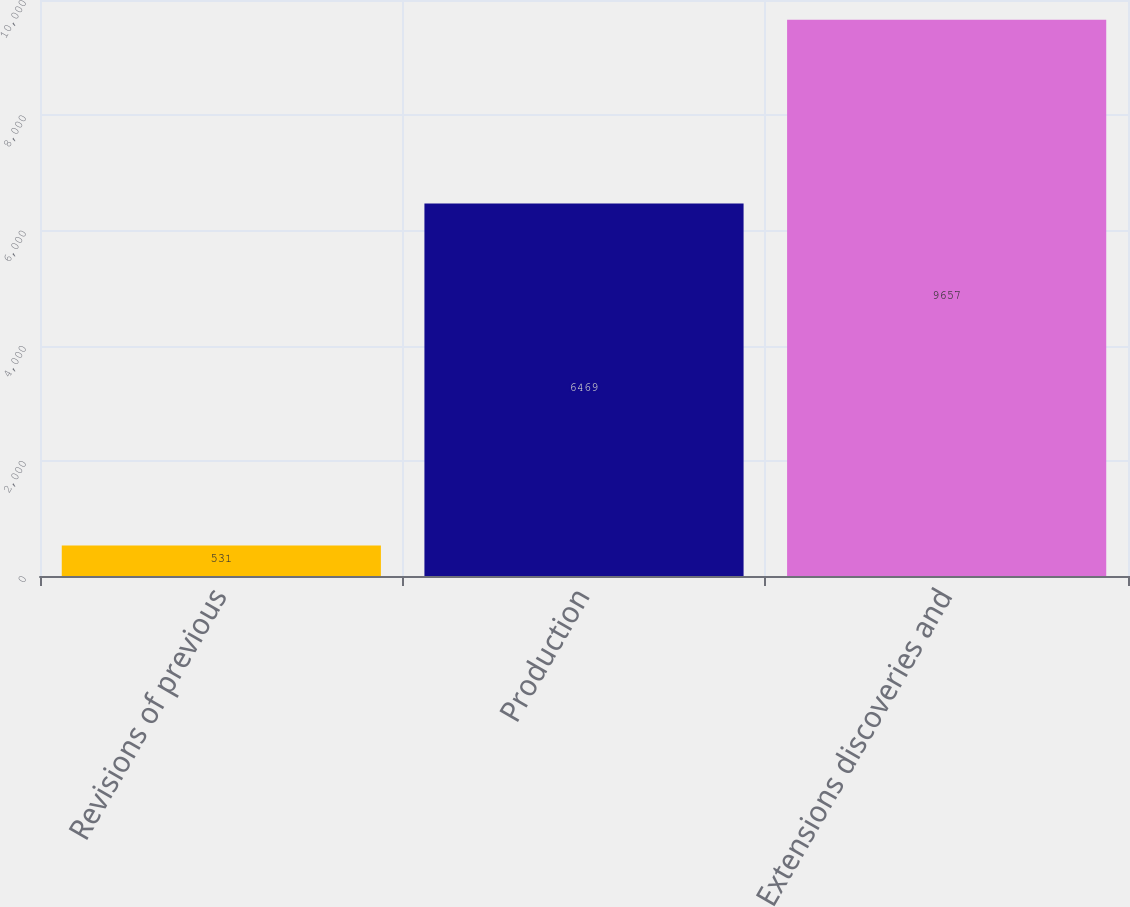Convert chart. <chart><loc_0><loc_0><loc_500><loc_500><bar_chart><fcel>Revisions of previous<fcel>Production<fcel>Extensions discoveries and<nl><fcel>531<fcel>6469<fcel>9657<nl></chart> 